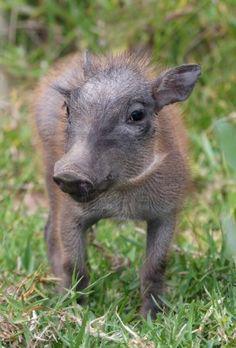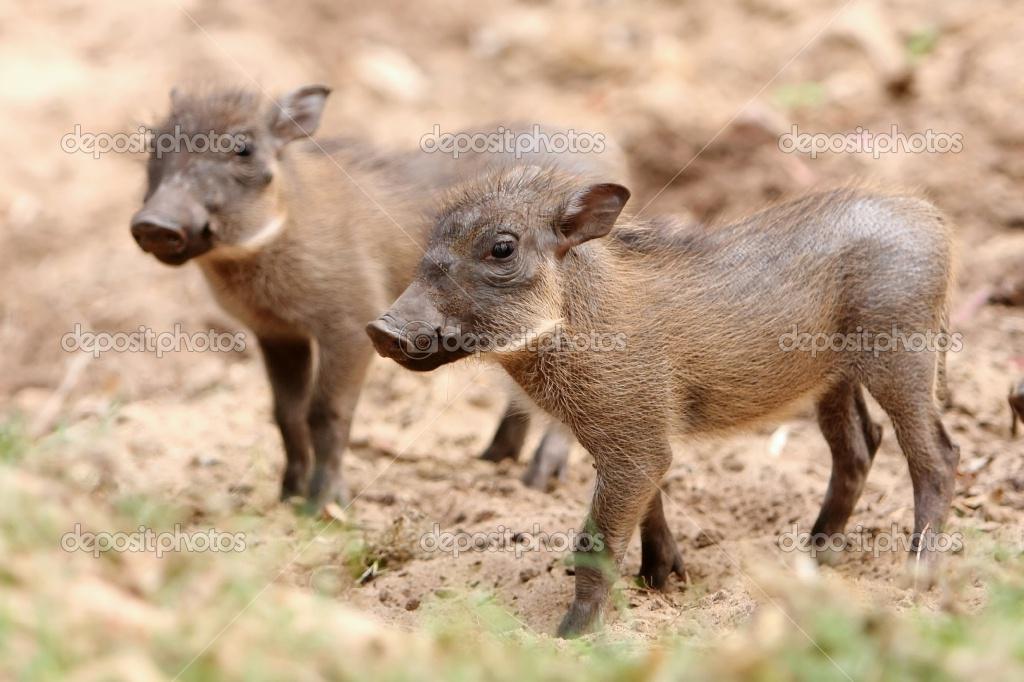The first image is the image on the left, the second image is the image on the right. Considering the images on both sides, is "Left image shows one young hog running forward." valid? Answer yes or no. No. The first image is the image on the left, the second image is the image on the right. Assess this claim about the two images: "There is exactly one animal in the image on the left.". Correct or not? Answer yes or no. Yes. 